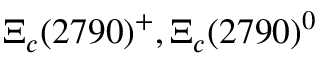Convert formula to latex. <formula><loc_0><loc_0><loc_500><loc_500>\Xi _ { c } ( 2 7 9 0 ) ^ { + } , \Xi _ { c } ( 2 7 9 0 ) ^ { 0 }</formula> 